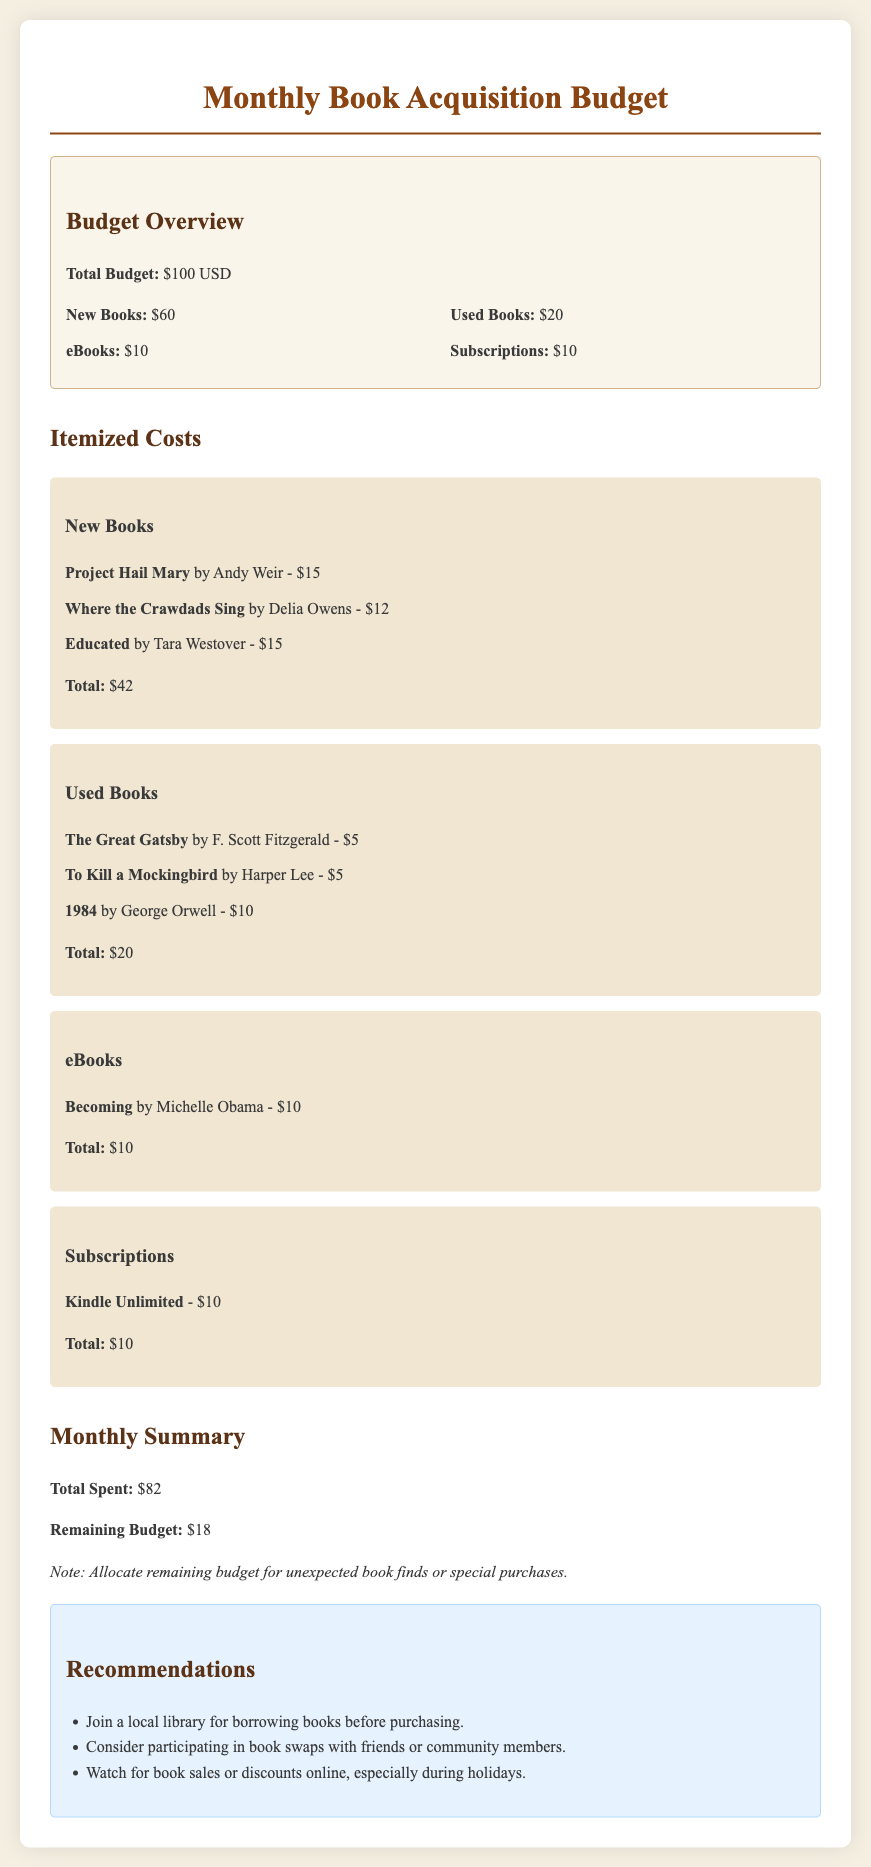What is the total budget? The total budget is outlined in the document as $100 USD.
Answer: $100 USD What is the cost of "Project Hail Mary"? The document lists "Project Hail Mary" by Andy Weir at a cost of $15.
Answer: $15 How much is allocated for used books? The budget overview shows that $20 is allocated for used books.
Answer: $20 What is the total spent this month? The monthly summary indicates that the total spent this month is $82.
Answer: $82 How much remains in the budget? The remaining budget is mentioned in the summary as $18.
Answer: $18 What is the total cost for eBooks? The itemized costs confirm that the total cost for eBooks is $10.
Answer: $10 What book is included in the subscriptions category? The subscriptions category lists "Kindle Unlimited" with a cost of $10.
Answer: Kindle Unlimited How many new books are listed? The document details three new books in the itemized costs section.
Answer: Three What recommendation is given for borrowing books? The recommendations suggest joining a local library for borrowing books.
Answer: Join a local library 